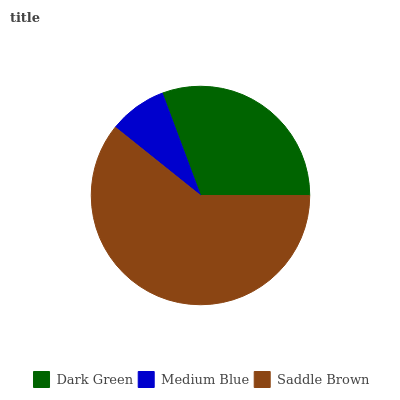Is Medium Blue the minimum?
Answer yes or no. Yes. Is Saddle Brown the maximum?
Answer yes or no. Yes. Is Saddle Brown the minimum?
Answer yes or no. No. Is Medium Blue the maximum?
Answer yes or no. No. Is Saddle Brown greater than Medium Blue?
Answer yes or no. Yes. Is Medium Blue less than Saddle Brown?
Answer yes or no. Yes. Is Medium Blue greater than Saddle Brown?
Answer yes or no. No. Is Saddle Brown less than Medium Blue?
Answer yes or no. No. Is Dark Green the high median?
Answer yes or no. Yes. Is Dark Green the low median?
Answer yes or no. Yes. Is Saddle Brown the high median?
Answer yes or no. No. Is Medium Blue the low median?
Answer yes or no. No. 